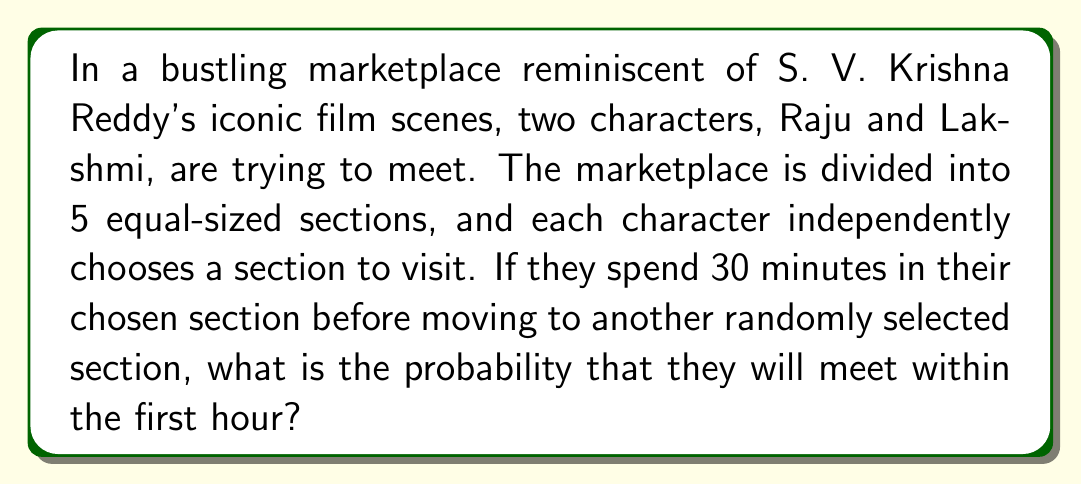Help me with this question. Let's approach this step-by-step:

1) For the first 30 minutes:
   - The probability of Raju and Lakshmi choosing the same section is $\frac{1}{5}$.
   - The probability of them not meeting in the first 30 minutes is $\frac{4}{5}$.

2) For the second 30 minutes:
   - If they didn't meet in the first 30 minutes, they each choose a new section independently.
   - The probability of them choosing the same section in this second attempt is again $\frac{1}{5}$.

3) The probability of them meeting within the hour is the sum of:
   a) The probability of meeting in the first 30 minutes
   b) The probability of not meeting in the first 30 minutes AND meeting in the second 30 minutes

4) We can express this mathematically as:

   $$P(\text{meeting}) = \frac{1}{5} + \frac{4}{5} \cdot \frac{1}{5}$$

5) Simplifying:
   $$P(\text{meeting}) = \frac{1}{5} + \frac{4}{25} = \frac{5}{25} + \frac{4}{25} = \frac{9}{25} = 0.36$$

Therefore, the probability of Raju and Lakshmi meeting within the first hour is $\frac{9}{25}$ or 0.36 or 36%.
Answer: $\frac{9}{25}$ 